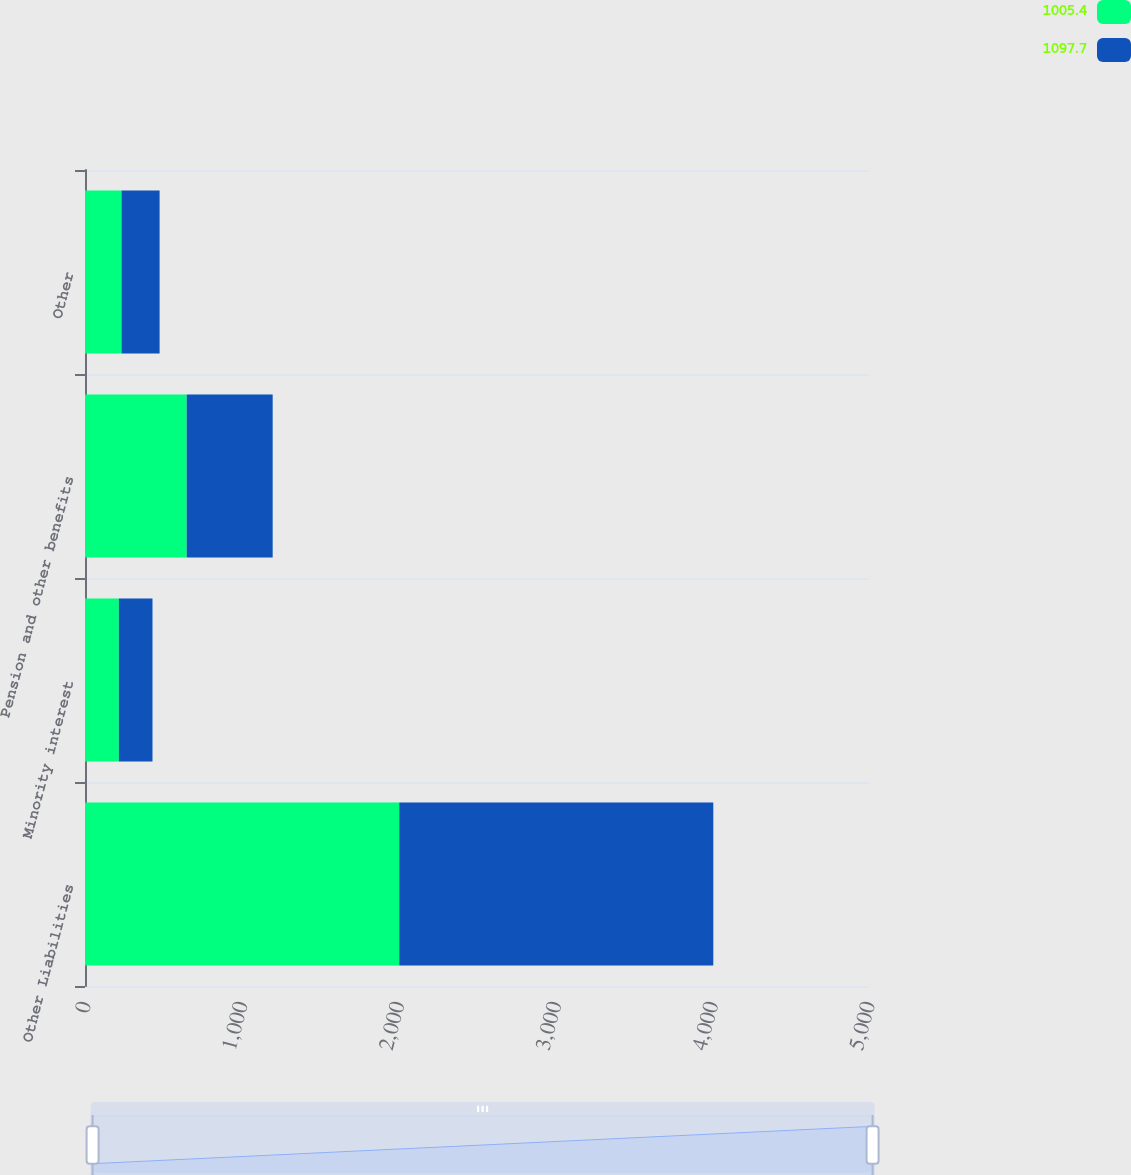Convert chart. <chart><loc_0><loc_0><loc_500><loc_500><stacked_bar_chart><ecel><fcel>Other Liabilities<fcel>Minority interest<fcel>Pension and other benefits<fcel>Other<nl><fcel>1005.4<fcel>2004<fcel>216<fcel>648.6<fcel>233.1<nl><fcel>1097.7<fcel>2003<fcel>214.4<fcel>548.3<fcel>242.7<nl></chart> 